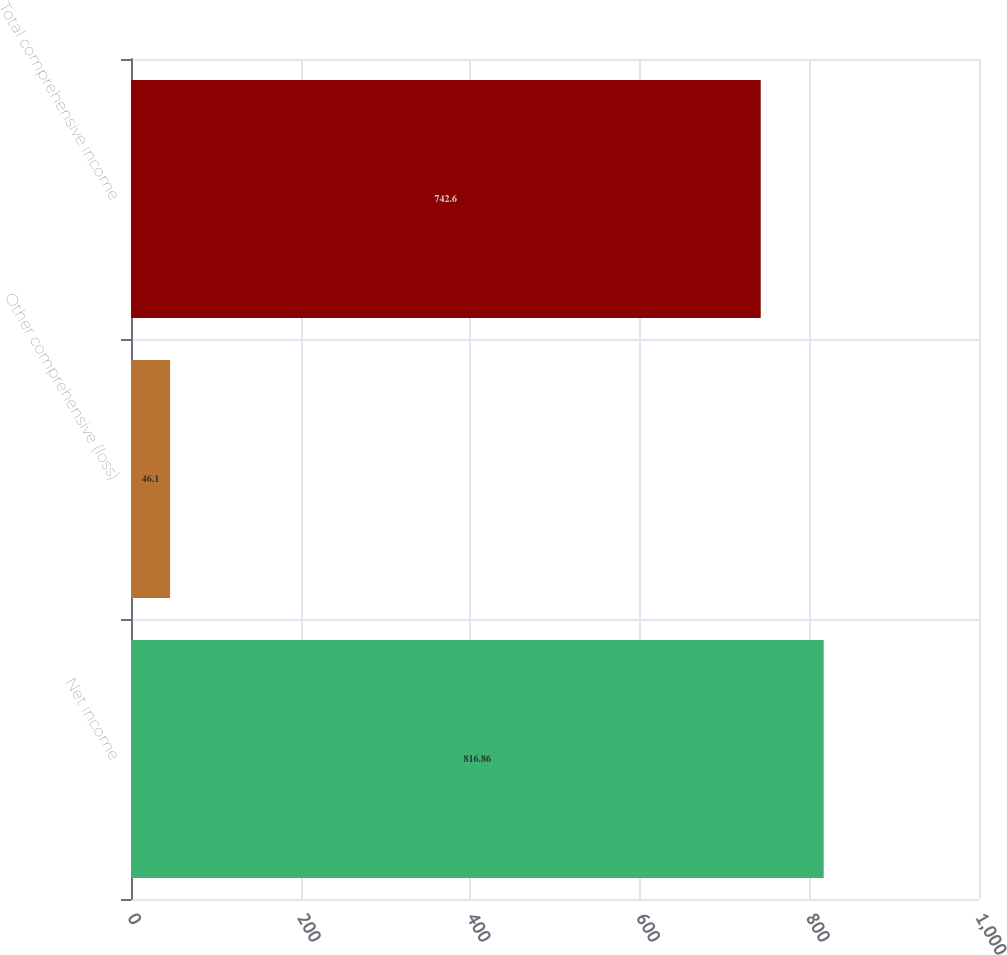Convert chart. <chart><loc_0><loc_0><loc_500><loc_500><bar_chart><fcel>Net income<fcel>Other comprehensive (loss)<fcel>Total comprehensive income<nl><fcel>816.86<fcel>46.1<fcel>742.6<nl></chart> 